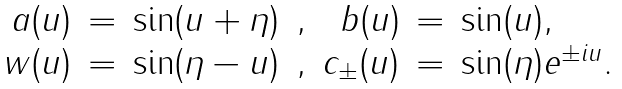<formula> <loc_0><loc_0><loc_500><loc_500>\begin{array} { r c l c r c l } a ( u ) & = & \sin ( u + \eta ) & , & b ( u ) & = & \sin ( u ) , \\ w ( u ) & = & \sin ( \eta - u ) & , & c _ { \pm } ( u ) & = & \sin ( { \eta } ) e ^ { \pm i u } . \end{array}</formula> 